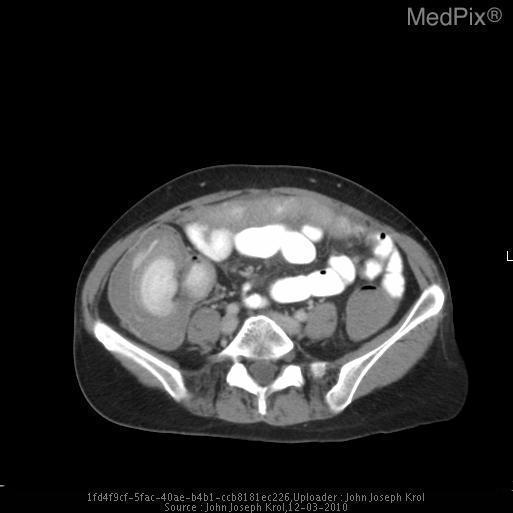Is there a pelvic fracture?
Concise answer only. No. Is the small bowel filled with contrast?
Quick response, please. Yes. Is the cecum dilated
Concise answer only. Yes. 